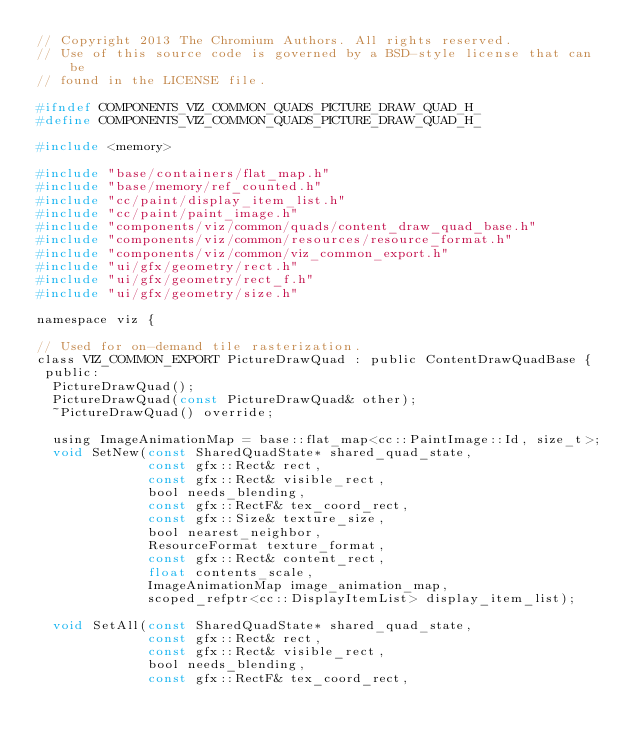<code> <loc_0><loc_0><loc_500><loc_500><_C_>// Copyright 2013 The Chromium Authors. All rights reserved.
// Use of this source code is governed by a BSD-style license that can be
// found in the LICENSE file.

#ifndef COMPONENTS_VIZ_COMMON_QUADS_PICTURE_DRAW_QUAD_H_
#define COMPONENTS_VIZ_COMMON_QUADS_PICTURE_DRAW_QUAD_H_

#include <memory>

#include "base/containers/flat_map.h"
#include "base/memory/ref_counted.h"
#include "cc/paint/display_item_list.h"
#include "cc/paint/paint_image.h"
#include "components/viz/common/quads/content_draw_quad_base.h"
#include "components/viz/common/resources/resource_format.h"
#include "components/viz/common/viz_common_export.h"
#include "ui/gfx/geometry/rect.h"
#include "ui/gfx/geometry/rect_f.h"
#include "ui/gfx/geometry/size.h"

namespace viz {

// Used for on-demand tile rasterization.
class VIZ_COMMON_EXPORT PictureDrawQuad : public ContentDrawQuadBase {
 public:
  PictureDrawQuad();
  PictureDrawQuad(const PictureDrawQuad& other);
  ~PictureDrawQuad() override;

  using ImageAnimationMap = base::flat_map<cc::PaintImage::Id, size_t>;
  void SetNew(const SharedQuadState* shared_quad_state,
              const gfx::Rect& rect,
              const gfx::Rect& visible_rect,
              bool needs_blending,
              const gfx::RectF& tex_coord_rect,
              const gfx::Size& texture_size,
              bool nearest_neighbor,
              ResourceFormat texture_format,
              const gfx::Rect& content_rect,
              float contents_scale,
              ImageAnimationMap image_animation_map,
              scoped_refptr<cc::DisplayItemList> display_item_list);

  void SetAll(const SharedQuadState* shared_quad_state,
              const gfx::Rect& rect,
              const gfx::Rect& visible_rect,
              bool needs_blending,
              const gfx::RectF& tex_coord_rect,</code> 